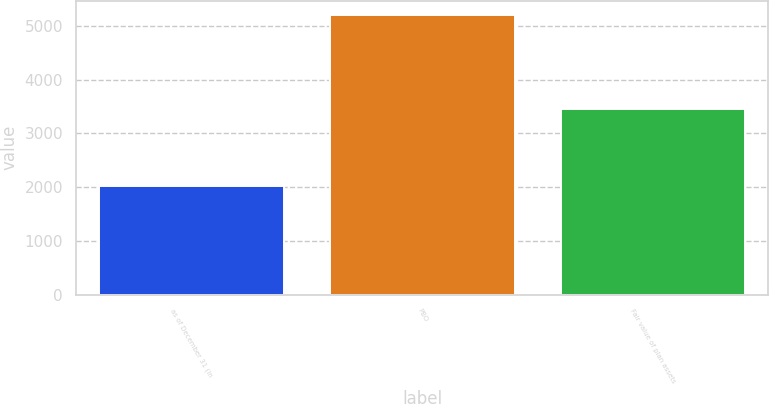Convert chart to OTSL. <chart><loc_0><loc_0><loc_500><loc_500><bar_chart><fcel>as of December 31 (in<fcel>PBO<fcel>Fair value of plan assets<nl><fcel>2012<fcel>5211<fcel>3452<nl></chart> 